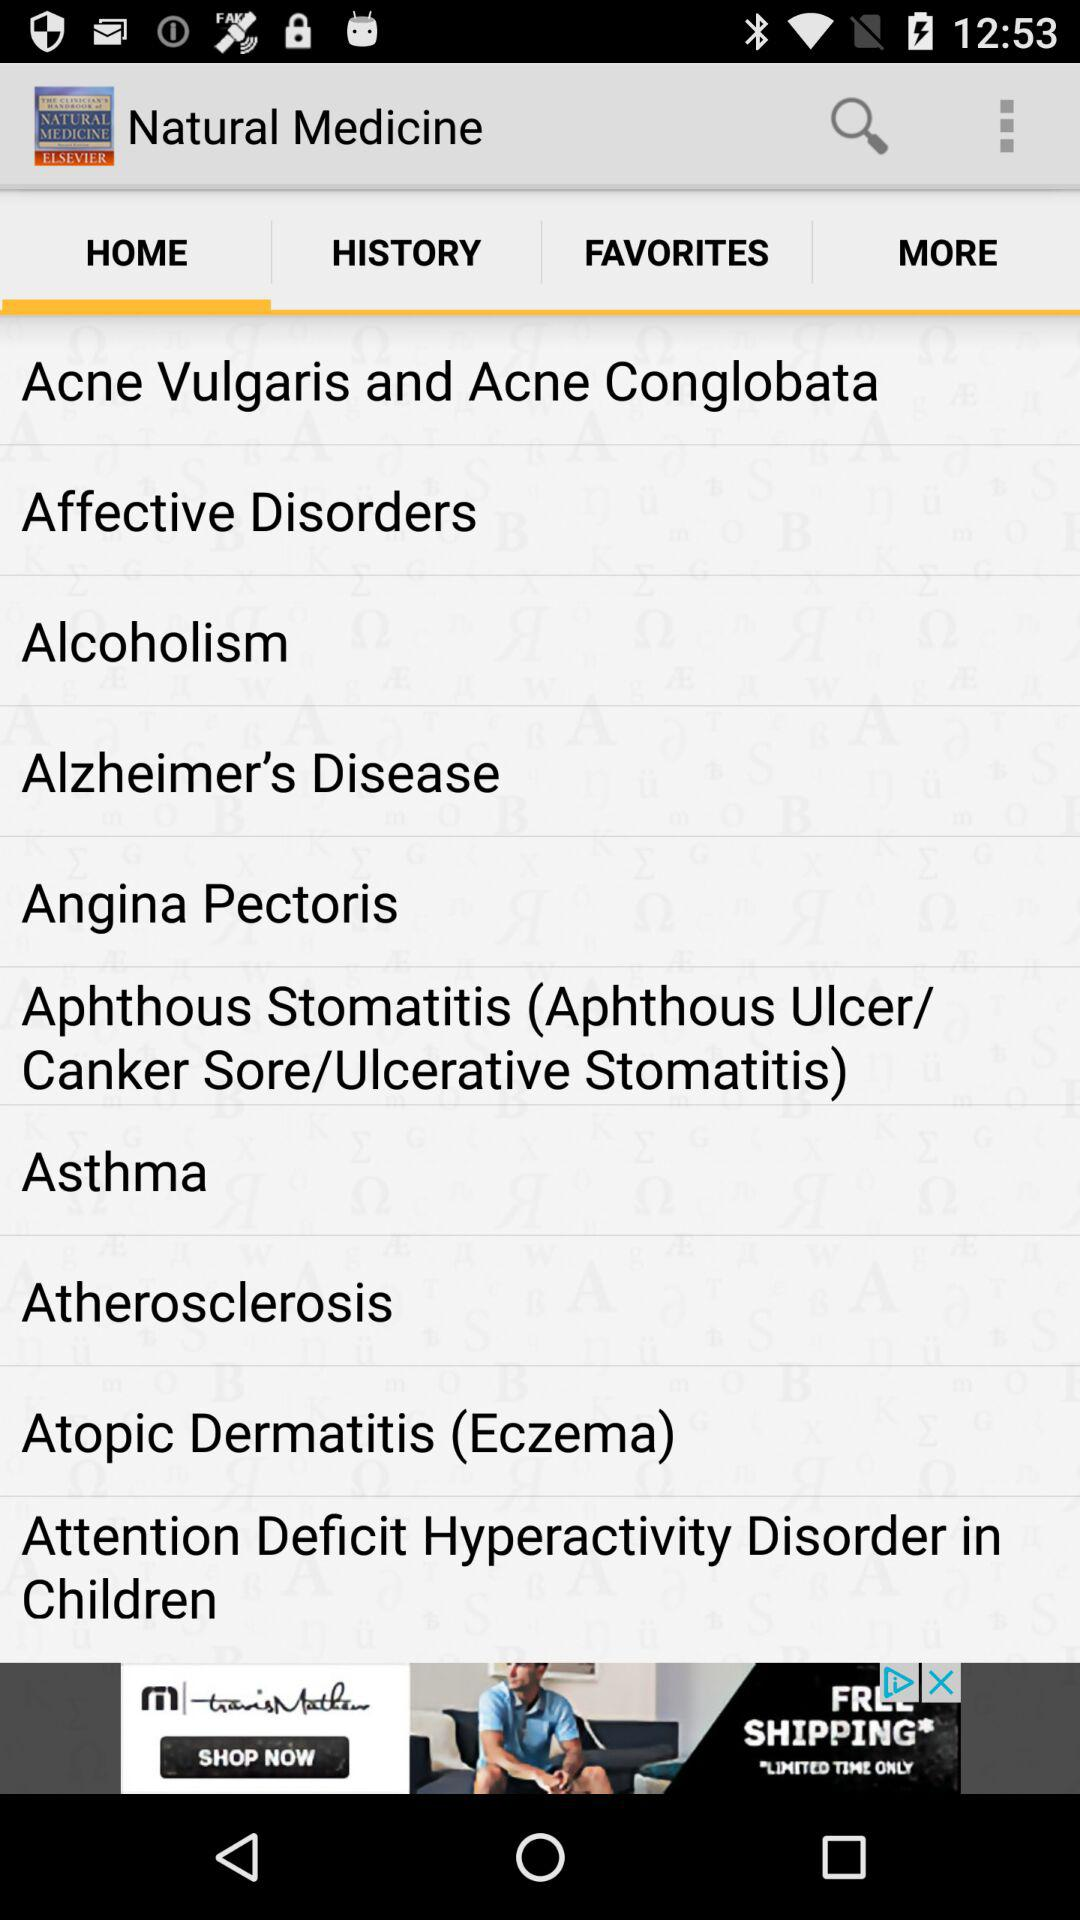Which tab is currently selected? The selected tab is "HOME". 